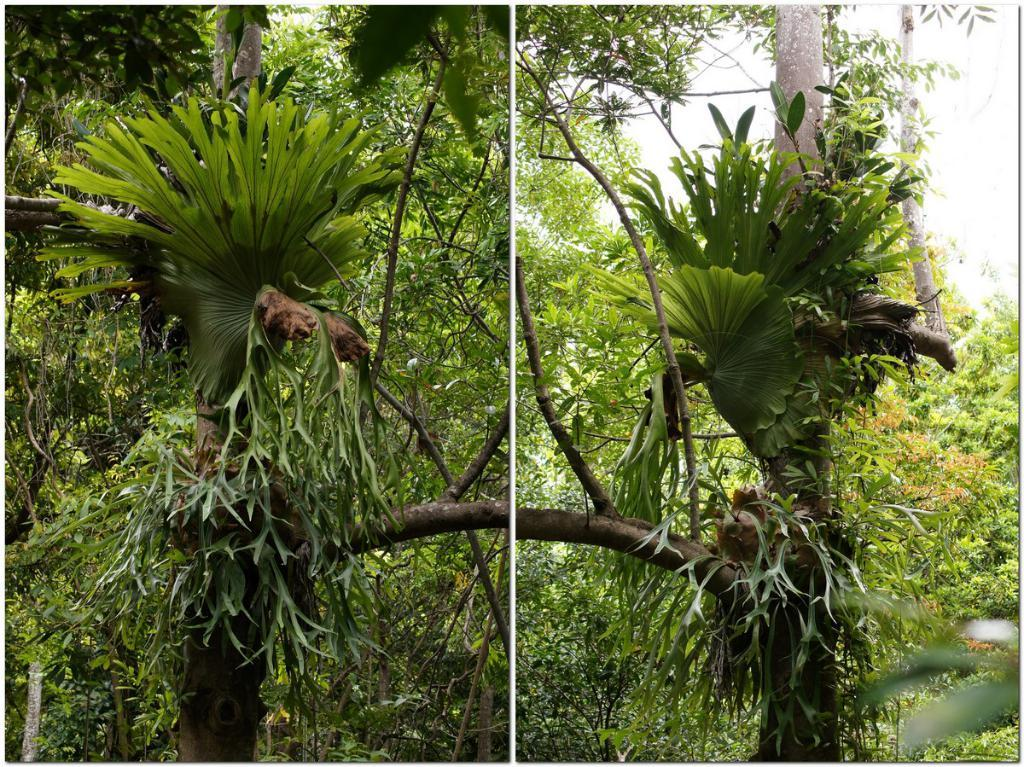What is the composition of the image? The image is a collage of two pictures. What is depicted in one of the pictures in the collage? One picture in the collage shows a group of trees. What is depicted in the other picture in the collage? The other picture in the collage shows the sky. What type of sun can be seen in the shoe in the image? There is no shoe or sun present in the image; it features a collage of two pictures, one showing a group of trees and the other showing the sky. 